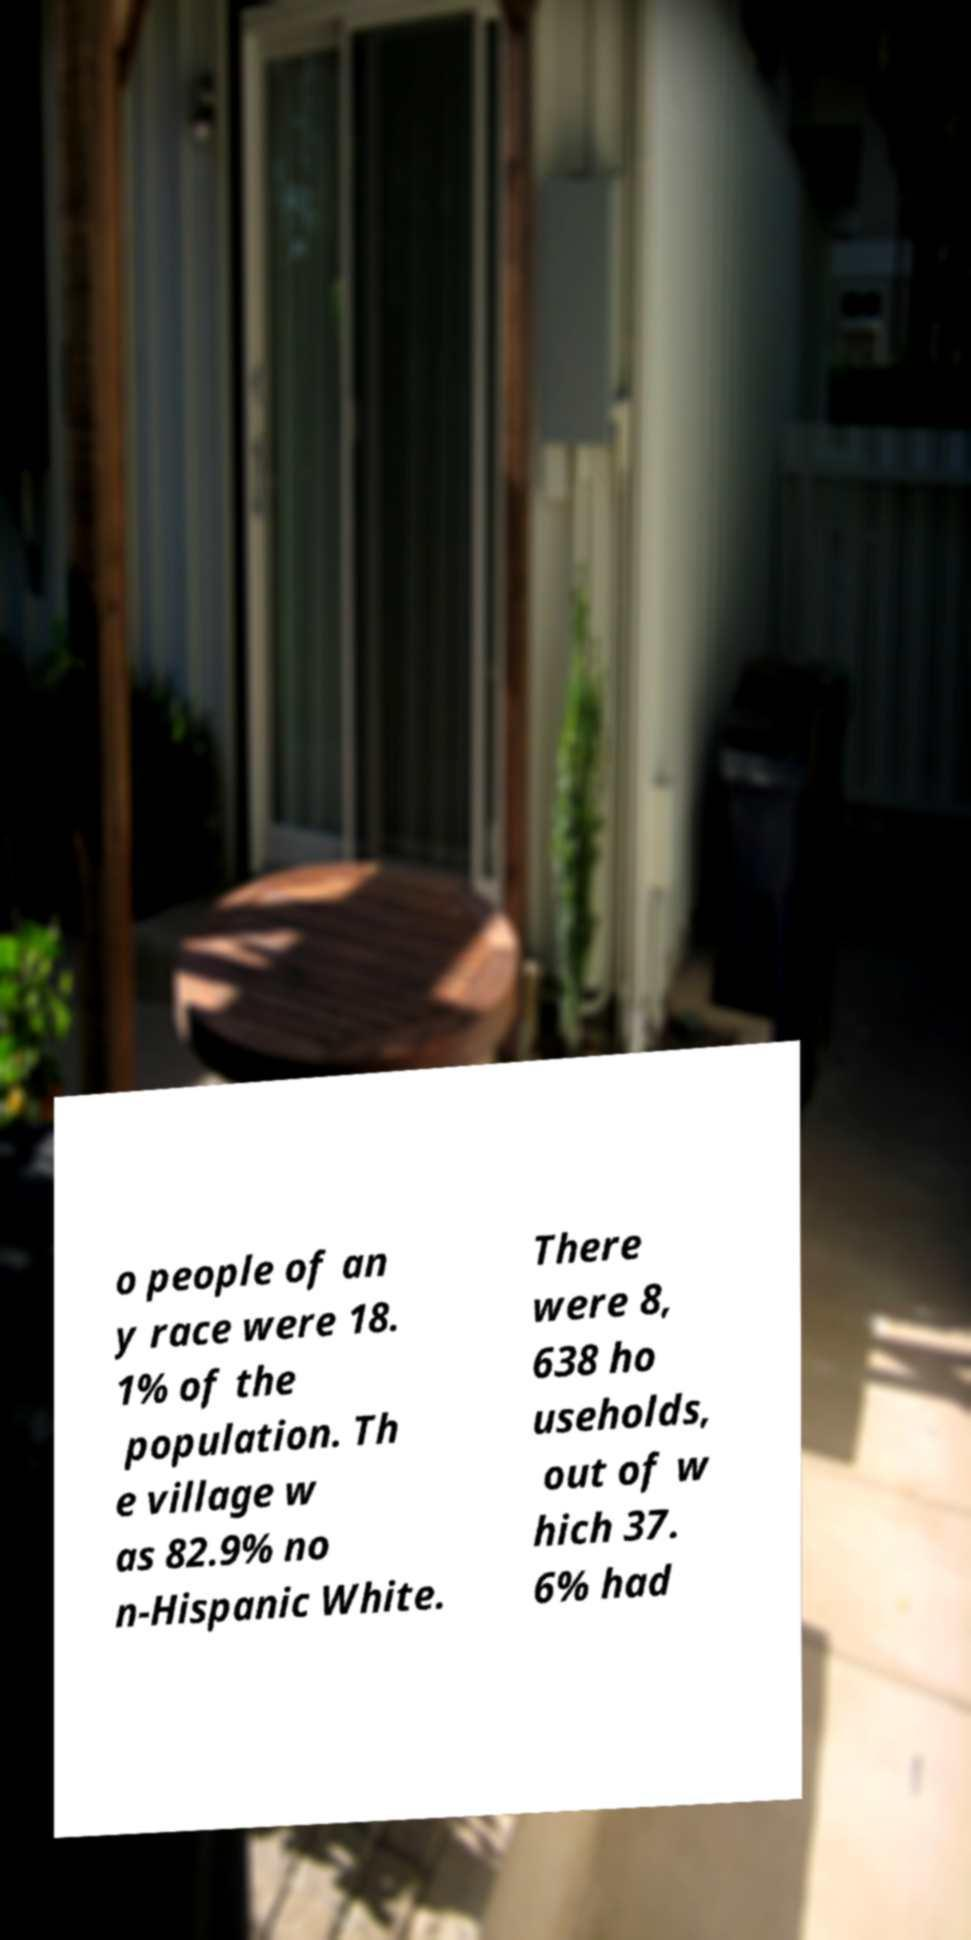Can you read and provide the text displayed in the image?This photo seems to have some interesting text. Can you extract and type it out for me? o people of an y race were 18. 1% of the population. Th e village w as 82.9% no n-Hispanic White. There were 8, 638 ho useholds, out of w hich 37. 6% had 